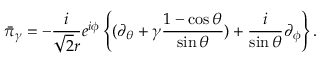Convert formula to latex. <formula><loc_0><loc_0><loc_500><loc_500>\bar { \pi } _ { \gamma } = - \frac { i } { \sqrt { 2 } r } e ^ { i \phi } \left \{ ( \partial _ { \theta } + \gamma \frac { 1 - \cos \theta } { \sin \theta } ) + \frac { i } { \sin \theta } \partial _ { \phi } \right \} .</formula> 